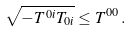Convert formula to latex. <formula><loc_0><loc_0><loc_500><loc_500>\sqrt { - T ^ { 0 i } T _ { 0 i } } \leq T ^ { 0 0 } \, .</formula> 